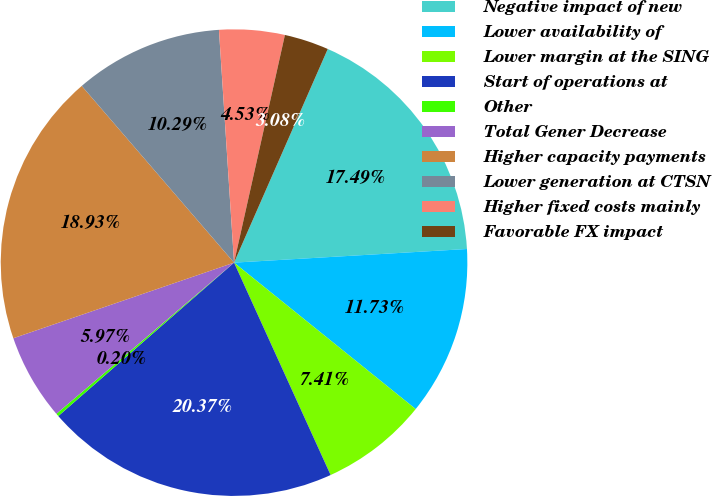<chart> <loc_0><loc_0><loc_500><loc_500><pie_chart><fcel>Negative impact of new<fcel>Lower availability of<fcel>Lower margin at the SING<fcel>Start of operations at<fcel>Other<fcel>Total Gener Decrease<fcel>Higher capacity payments<fcel>Lower generation at CTSN<fcel>Higher fixed costs mainly<fcel>Favorable FX impact<nl><fcel>17.49%<fcel>11.73%<fcel>7.41%<fcel>20.37%<fcel>0.2%<fcel>5.97%<fcel>18.93%<fcel>10.29%<fcel>4.53%<fcel>3.08%<nl></chart> 